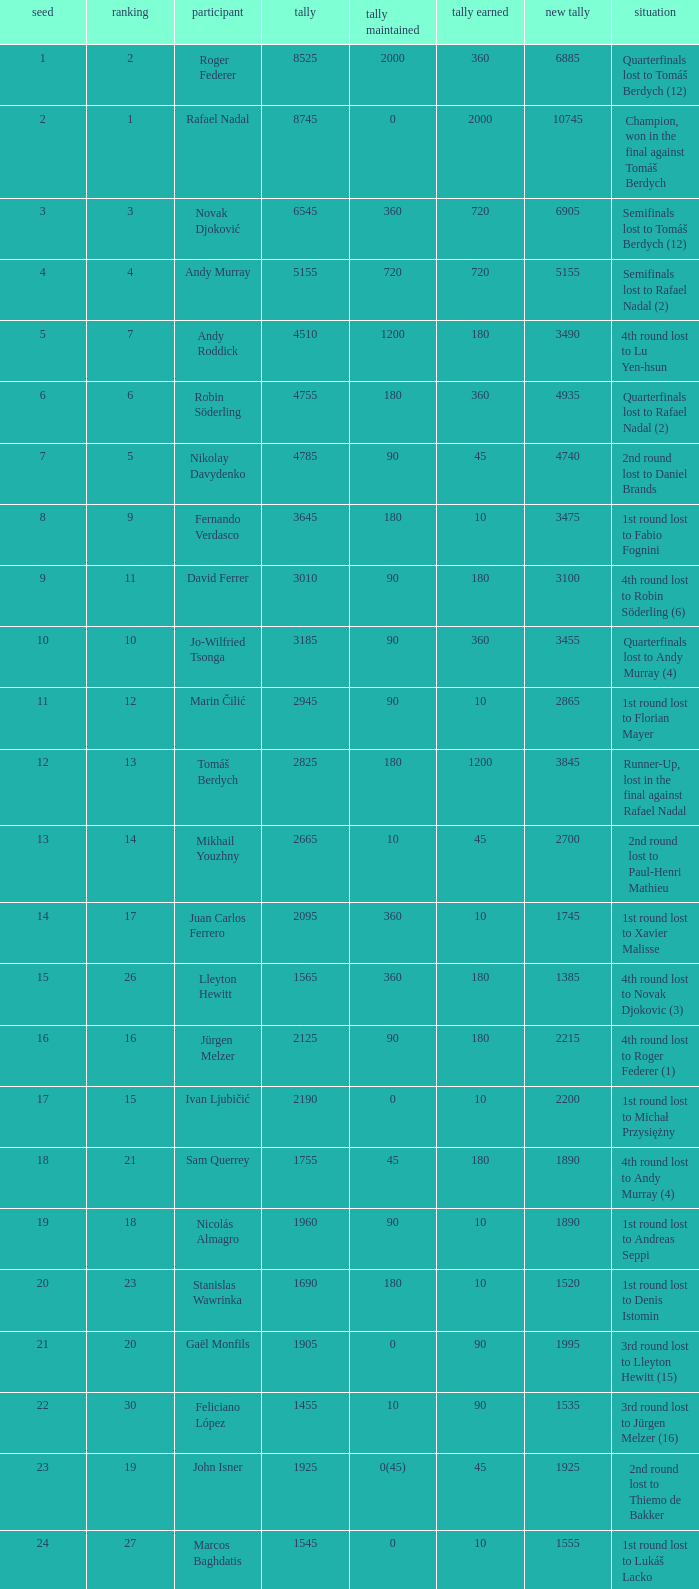Name the least new points for points defending is 1200 3490.0. 